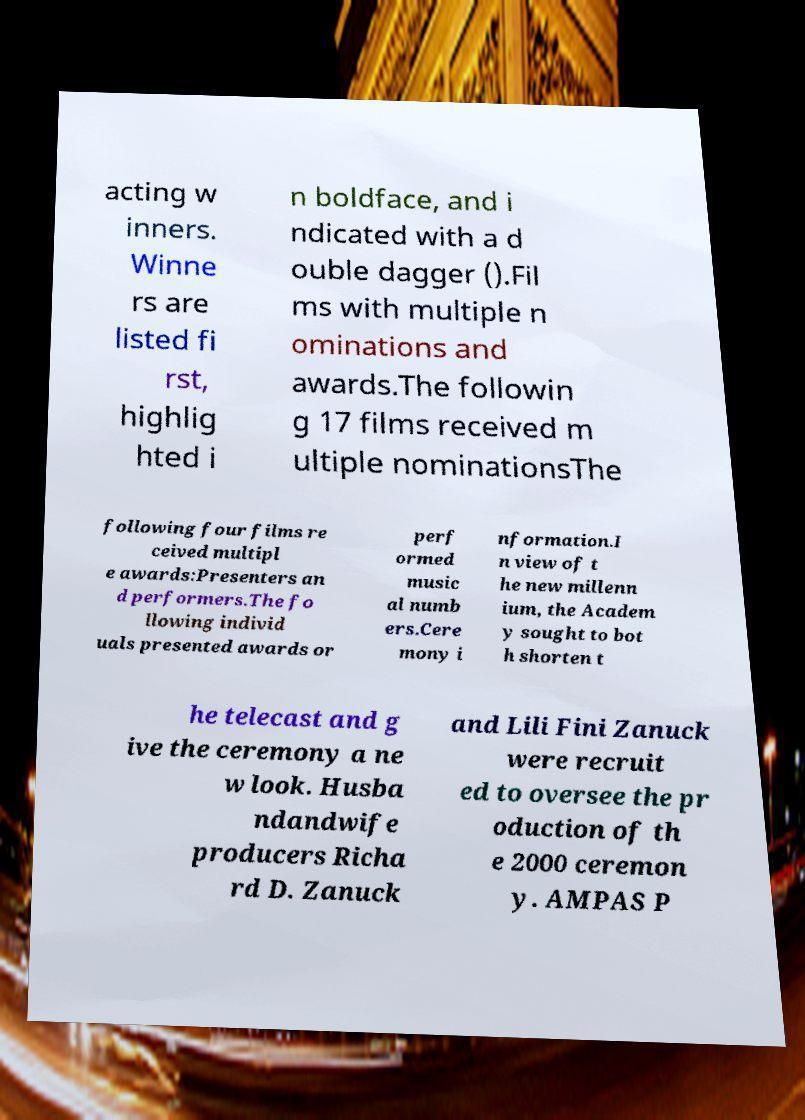For documentation purposes, I need the text within this image transcribed. Could you provide that? acting w inners. Winne rs are listed fi rst, highlig hted i n boldface, and i ndicated with a d ouble dagger ().Fil ms with multiple n ominations and awards.The followin g 17 films received m ultiple nominationsThe following four films re ceived multipl e awards:Presenters an d performers.The fo llowing individ uals presented awards or perf ormed music al numb ers.Cere mony i nformation.I n view of t he new millenn ium, the Academ y sought to bot h shorten t he telecast and g ive the ceremony a ne w look. Husba ndandwife producers Richa rd D. Zanuck and Lili Fini Zanuck were recruit ed to oversee the pr oduction of th e 2000 ceremon y. AMPAS P 